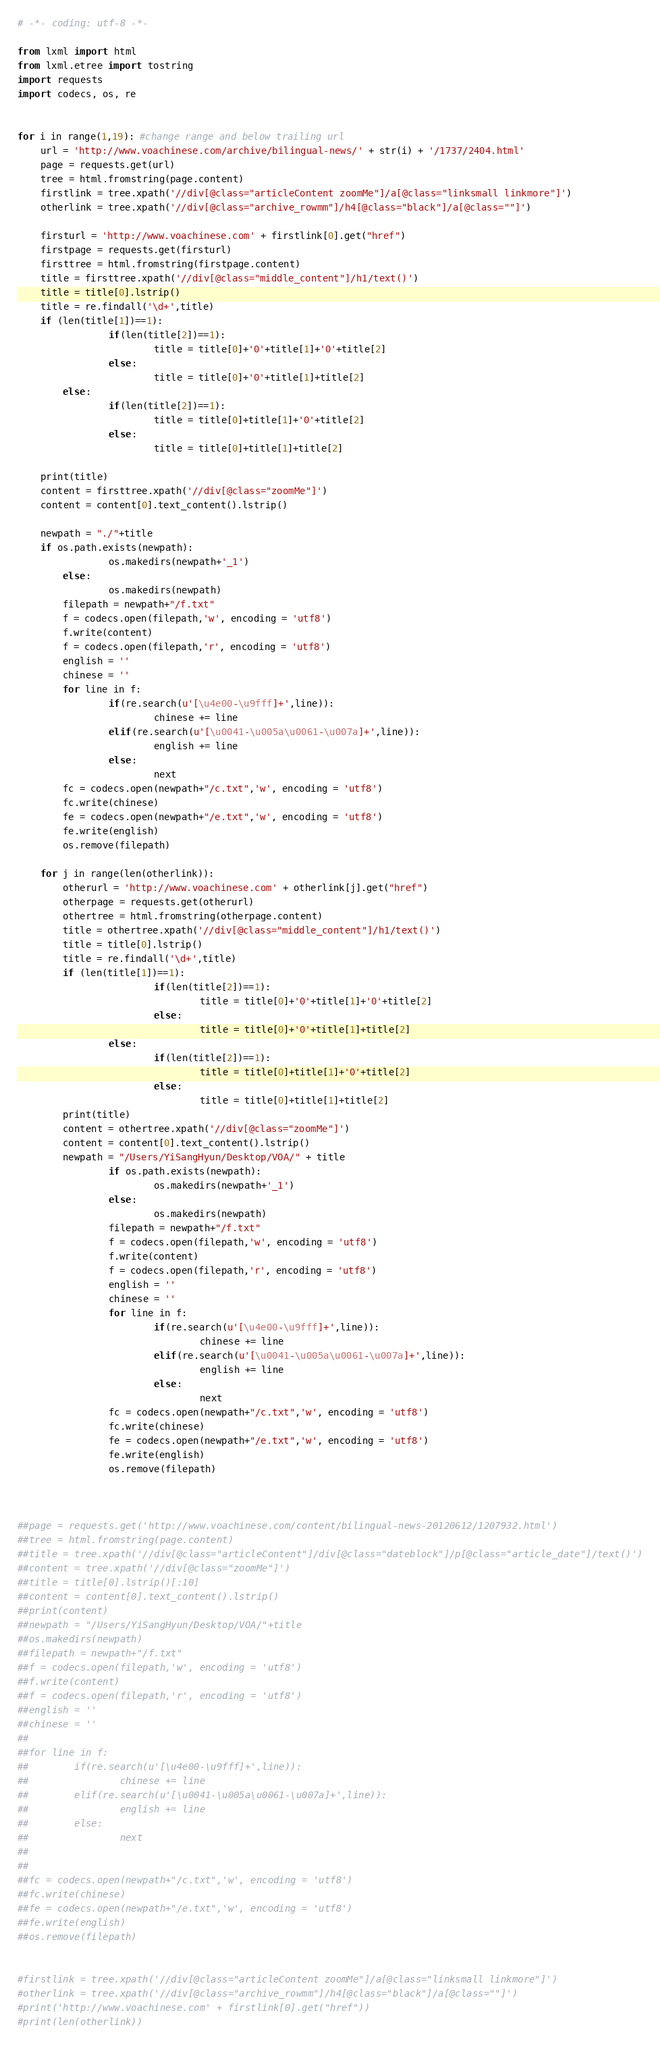<code> <loc_0><loc_0><loc_500><loc_500><_Python_># -*- coding: utf-8 -*-

from lxml import html
from lxml.etree import tostring
import requests
import codecs, os, re


for i in range(1,19): #change range and below trailing url
	url = 'http://www.voachinese.com/archive/bilingual-news/' + str(i) + '/1737/2404.html'
	page = requests.get(url)
	tree = html.fromstring(page.content)
	firstlink = tree.xpath('//div[@class="articleContent zoomMe"]/a[@class="linksmall linkmore"]')
	otherlink = tree.xpath('//div[@class="archive_rowmm"]/h4[@class="black"]/a[@class=""]')

	firsturl = 'http://www.voachinese.com' + firstlink[0].get("href")
	firstpage = requests.get(firsturl)
	firsttree = html.fromstring(firstpage.content)
	title = firsttree.xpath('//div[@class="middle_content"]/h1/text()')
	title = title[0].lstrip()
	title = re.findall('\d+',title)
	if (len(title[1])==1):
                if(len(title[2])==1):
                        title = title[0]+'0'+title[1]+'0'+title[2]
                else:
                        title = title[0]+'0'+title[1]+title[2]
        else:
                if(len(title[2])==1):
                        title = title[0]+title[1]+'0'+title[2]
                else:
                        title = title[0]+title[1]+title[2]
                   
	print(title)
	content = firsttree.xpath('//div[@class="zoomMe"]')
	content = content[0].text_content().lstrip()
	
	newpath = "./"+title
	if os.path.exists(newpath):
                os.makedirs(newpath+'_1')
        else:
                os.makedirs(newpath)
        filepath = newpath+"/f.txt"
        f = codecs.open(filepath,'w', encoding = 'utf8')
        f.write(content)
        f = codecs.open(filepath,'r', encoding = 'utf8')
        english = ''
        chinese = ''
        for line in f:
                if(re.search(u'[\u4e00-\u9fff]+',line)):
                        chinese += line
                elif(re.search(u'[\u0041-\u005a\u0061-\u007a]+',line)):
                        english += line
                else:
                        next
        fc = codecs.open(newpath+"/c.txt",'w', encoding = 'utf8')
        fc.write(chinese)
        fe = codecs.open(newpath+"/e.txt",'w', encoding = 'utf8')
        fe.write(english)
        os.remove(filepath)
        
	for j in range(len(otherlink)):
		otherurl = 'http://www.voachinese.com' + otherlink[j].get("href")
		otherpage = requests.get(otherurl)
		othertree = html.fromstring(otherpage.content)
		title = othertree.xpath('//div[@class="middle_content"]/h1/text()')
		title = title[0].lstrip()
		title = re.findall('\d+',title)
		if (len(title[1])==1):
                        if(len(title[2])==1):
                                title = title[0]+'0'+title[1]+'0'+title[2]
                        else:
                                title = title[0]+'0'+title[1]+title[2]
                else:
                        if(len(title[2])==1):
                                title = title[0]+title[1]+'0'+title[2]
                        else:
                                title = title[0]+title[1]+title[2]
		print(title)
		content = othertree.xpath('//div[@class="zoomMe"]')
		content = content[0].text_content().lstrip()
		newpath = "/Users/YiSangHyun/Desktop/VOA/" + title
                if os.path.exists(newpath):
                        os.makedirs(newpath+'_1')
                else:
                        os.makedirs(newpath)
                filepath = newpath+"/f.txt"
                f = codecs.open(filepath,'w', encoding = 'utf8')
                f.write(content)
                f = codecs.open(filepath,'r', encoding = 'utf8')
                english = ''
                chinese = ''
                for line in f:
                        if(re.search(u'[\u4e00-\u9fff]+',line)):
                                chinese += line
                        elif(re.search(u'[\u0041-\u005a\u0061-\u007a]+',line)):
                                english += line
                        else:
                                next
                fc = codecs.open(newpath+"/c.txt",'w', encoding = 'utf8')
                fc.write(chinese)
                fe = codecs.open(newpath+"/e.txt",'w', encoding = 'utf8')
                fe.write(english)
                os.remove(filepath)


	
##page = requests.get('http://www.voachinese.com/content/bilingual-news-20120612/1207932.html')
##tree = html.fromstring(page.content)
##title = tree.xpath('//div[@class="articleContent"]/div[@class="dateblock"]/p[@class="article_date"]/text()')
##content = tree.xpath('//div[@class="zoomMe"]') 
##title = title[0].lstrip()[:10]
##content = content[0].text_content().lstrip()
##print(content)
##newpath = "/Users/YiSangHyun/Desktop/VOA/"+title
##os.makedirs(newpath)
##filepath = newpath+"/f.txt"
##f = codecs.open(filepath,'w', encoding = 'utf8')
##f.write(content)
##f = codecs.open(filepath,'r', encoding = 'utf8')
##english = ''
##chinese = ''
##
##for line in f:
##        if(re.search(u'[\u4e00-\u9fff]+',line)):
##                chinese += line
##        elif(re.search(u'[\u0041-\u005a\u0061-\u007a]+',line)):
##                english += line
##        else:
##                next
##
##                        
##fc = codecs.open(newpath+"/c.txt",'w', encoding = 'utf8')
##fc.write(chinese)
##fe = codecs.open(newpath+"/e.txt",'w', encoding = 'utf8')
##fe.write(english)
##os.remove(filepath)


#firstlink = tree.xpath('//div[@class="articleContent zoomMe"]/a[@class="linksmall linkmore"]')
#otherlink = tree.xpath('//div[@class="archive_rowmm"]/h4[@class="black"]/a[@class=""]')
#print('http://www.voachinese.com' + firstlink[0].get("href"))
#print(len(otherlink))


</code> 